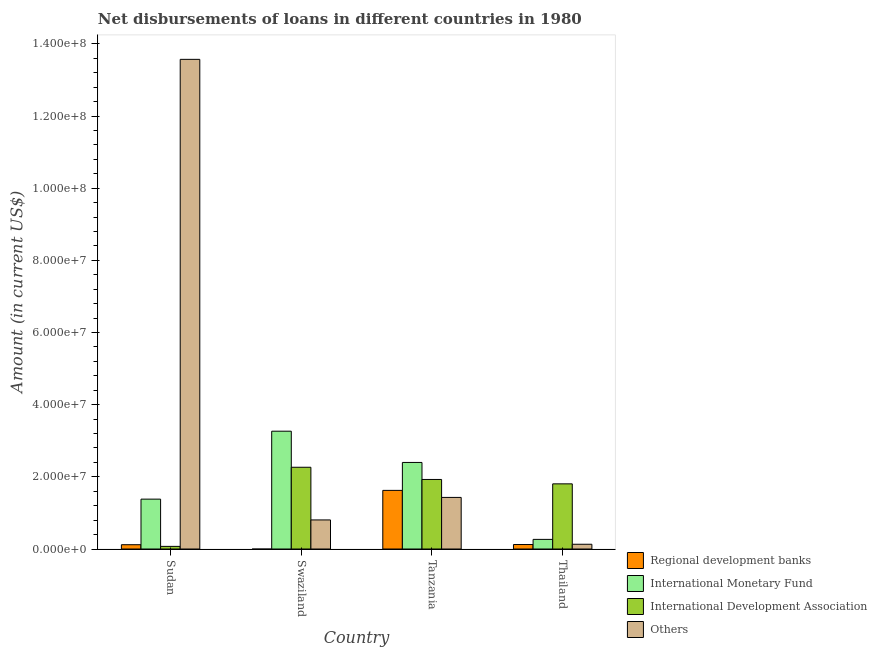How many different coloured bars are there?
Your answer should be compact. 4. Are the number of bars per tick equal to the number of legend labels?
Your answer should be compact. No. How many bars are there on the 1st tick from the left?
Keep it short and to the point. 4. What is the label of the 4th group of bars from the left?
Give a very brief answer. Thailand. In how many cases, is the number of bars for a given country not equal to the number of legend labels?
Offer a very short reply. 1. What is the amount of loan disimbursed by international development association in Swaziland?
Your answer should be very brief. 2.27e+07. Across all countries, what is the maximum amount of loan disimbursed by regional development banks?
Your answer should be compact. 1.62e+07. Across all countries, what is the minimum amount of loan disimbursed by international development association?
Your answer should be very brief. 7.26e+05. In which country was the amount of loan disimbursed by international monetary fund maximum?
Provide a succinct answer. Swaziland. What is the total amount of loan disimbursed by international development association in the graph?
Ensure brevity in your answer.  6.07e+07. What is the difference between the amount of loan disimbursed by other organisations in Tanzania and that in Thailand?
Make the answer very short. 1.30e+07. What is the difference between the amount of loan disimbursed by international monetary fund in Thailand and the amount of loan disimbursed by other organisations in Tanzania?
Your response must be concise. -1.16e+07. What is the average amount of loan disimbursed by regional development banks per country?
Provide a short and direct response. 4.67e+06. What is the difference between the amount of loan disimbursed by other organisations and amount of loan disimbursed by regional development banks in Sudan?
Provide a short and direct response. 1.35e+08. In how many countries, is the amount of loan disimbursed by international monetary fund greater than 80000000 US$?
Offer a terse response. 0. What is the ratio of the amount of loan disimbursed by regional development banks in Sudan to that in Thailand?
Make the answer very short. 0.96. Is the difference between the amount of loan disimbursed by other organisations in Tanzania and Thailand greater than the difference between the amount of loan disimbursed by international development association in Tanzania and Thailand?
Your response must be concise. Yes. What is the difference between the highest and the second highest amount of loan disimbursed by regional development banks?
Make the answer very short. 1.50e+07. What is the difference between the highest and the lowest amount of loan disimbursed by regional development banks?
Provide a short and direct response. 1.62e+07. Is it the case that in every country, the sum of the amount of loan disimbursed by regional development banks and amount of loan disimbursed by other organisations is greater than the sum of amount of loan disimbursed by international monetary fund and amount of loan disimbursed by international development association?
Offer a terse response. No. How many bars are there?
Your response must be concise. 15. Are the values on the major ticks of Y-axis written in scientific E-notation?
Your answer should be very brief. Yes. Does the graph contain any zero values?
Offer a terse response. Yes. Where does the legend appear in the graph?
Give a very brief answer. Bottom right. What is the title of the graph?
Your answer should be very brief. Net disbursements of loans in different countries in 1980. What is the Amount (in current US$) of Regional development banks in Sudan?
Your response must be concise. 1.19e+06. What is the Amount (in current US$) in International Monetary Fund in Sudan?
Offer a terse response. 1.38e+07. What is the Amount (in current US$) of International Development Association in Sudan?
Ensure brevity in your answer.  7.26e+05. What is the Amount (in current US$) in Others in Sudan?
Your answer should be very brief. 1.36e+08. What is the Amount (in current US$) in Regional development banks in Swaziland?
Your response must be concise. 0. What is the Amount (in current US$) in International Monetary Fund in Swaziland?
Provide a succinct answer. 3.27e+07. What is the Amount (in current US$) of International Development Association in Swaziland?
Your answer should be very brief. 2.27e+07. What is the Amount (in current US$) of Others in Swaziland?
Offer a very short reply. 8.06e+06. What is the Amount (in current US$) of Regional development banks in Tanzania?
Provide a short and direct response. 1.62e+07. What is the Amount (in current US$) in International Monetary Fund in Tanzania?
Keep it short and to the point. 2.40e+07. What is the Amount (in current US$) in International Development Association in Tanzania?
Your response must be concise. 1.93e+07. What is the Amount (in current US$) of Others in Tanzania?
Keep it short and to the point. 1.43e+07. What is the Amount (in current US$) of Regional development banks in Thailand?
Keep it short and to the point. 1.24e+06. What is the Amount (in current US$) of International Monetary Fund in Thailand?
Provide a short and direct response. 2.67e+06. What is the Amount (in current US$) of International Development Association in Thailand?
Make the answer very short. 1.81e+07. What is the Amount (in current US$) in Others in Thailand?
Provide a short and direct response. 1.32e+06. Across all countries, what is the maximum Amount (in current US$) in Regional development banks?
Make the answer very short. 1.62e+07. Across all countries, what is the maximum Amount (in current US$) in International Monetary Fund?
Your answer should be compact. 3.27e+07. Across all countries, what is the maximum Amount (in current US$) in International Development Association?
Your response must be concise. 2.27e+07. Across all countries, what is the maximum Amount (in current US$) of Others?
Your answer should be compact. 1.36e+08. Across all countries, what is the minimum Amount (in current US$) in International Monetary Fund?
Give a very brief answer. 2.67e+06. Across all countries, what is the minimum Amount (in current US$) of International Development Association?
Keep it short and to the point. 7.26e+05. Across all countries, what is the minimum Amount (in current US$) in Others?
Your response must be concise. 1.32e+06. What is the total Amount (in current US$) of Regional development banks in the graph?
Your response must be concise. 1.87e+07. What is the total Amount (in current US$) of International Monetary Fund in the graph?
Your response must be concise. 7.31e+07. What is the total Amount (in current US$) in International Development Association in the graph?
Offer a terse response. 6.07e+07. What is the total Amount (in current US$) in Others in the graph?
Give a very brief answer. 1.59e+08. What is the difference between the Amount (in current US$) in International Monetary Fund in Sudan and that in Swaziland?
Make the answer very short. -1.88e+07. What is the difference between the Amount (in current US$) in International Development Association in Sudan and that in Swaziland?
Your answer should be compact. -2.19e+07. What is the difference between the Amount (in current US$) in Others in Sudan and that in Swaziland?
Keep it short and to the point. 1.28e+08. What is the difference between the Amount (in current US$) of Regional development banks in Sudan and that in Tanzania?
Make the answer very short. -1.51e+07. What is the difference between the Amount (in current US$) in International Monetary Fund in Sudan and that in Tanzania?
Give a very brief answer. -1.02e+07. What is the difference between the Amount (in current US$) in International Development Association in Sudan and that in Tanzania?
Give a very brief answer. -1.86e+07. What is the difference between the Amount (in current US$) of Others in Sudan and that in Tanzania?
Provide a short and direct response. 1.21e+08. What is the difference between the Amount (in current US$) in Regional development banks in Sudan and that in Thailand?
Offer a terse response. -5.30e+04. What is the difference between the Amount (in current US$) of International Monetary Fund in Sudan and that in Thailand?
Ensure brevity in your answer.  1.12e+07. What is the difference between the Amount (in current US$) in International Development Association in Sudan and that in Thailand?
Provide a succinct answer. -1.73e+07. What is the difference between the Amount (in current US$) of Others in Sudan and that in Thailand?
Provide a succinct answer. 1.34e+08. What is the difference between the Amount (in current US$) in International Monetary Fund in Swaziland and that in Tanzania?
Ensure brevity in your answer.  8.66e+06. What is the difference between the Amount (in current US$) in International Development Association in Swaziland and that in Tanzania?
Your answer should be very brief. 3.38e+06. What is the difference between the Amount (in current US$) in Others in Swaziland and that in Tanzania?
Your response must be concise. -6.24e+06. What is the difference between the Amount (in current US$) of International Monetary Fund in Swaziland and that in Thailand?
Make the answer very short. 3.00e+07. What is the difference between the Amount (in current US$) of International Development Association in Swaziland and that in Thailand?
Your answer should be very brief. 4.60e+06. What is the difference between the Amount (in current US$) in Others in Swaziland and that in Thailand?
Make the answer very short. 6.74e+06. What is the difference between the Amount (in current US$) of Regional development banks in Tanzania and that in Thailand?
Provide a short and direct response. 1.50e+07. What is the difference between the Amount (in current US$) of International Monetary Fund in Tanzania and that in Thailand?
Offer a very short reply. 2.13e+07. What is the difference between the Amount (in current US$) in International Development Association in Tanzania and that in Thailand?
Offer a terse response. 1.22e+06. What is the difference between the Amount (in current US$) in Others in Tanzania and that in Thailand?
Ensure brevity in your answer.  1.30e+07. What is the difference between the Amount (in current US$) in Regional development banks in Sudan and the Amount (in current US$) in International Monetary Fund in Swaziland?
Offer a very short reply. -3.15e+07. What is the difference between the Amount (in current US$) in Regional development banks in Sudan and the Amount (in current US$) in International Development Association in Swaziland?
Your answer should be very brief. -2.15e+07. What is the difference between the Amount (in current US$) of Regional development banks in Sudan and the Amount (in current US$) of Others in Swaziland?
Your response must be concise. -6.87e+06. What is the difference between the Amount (in current US$) in International Monetary Fund in Sudan and the Amount (in current US$) in International Development Association in Swaziland?
Your answer should be very brief. -8.83e+06. What is the difference between the Amount (in current US$) in International Monetary Fund in Sudan and the Amount (in current US$) in Others in Swaziland?
Your response must be concise. 5.76e+06. What is the difference between the Amount (in current US$) of International Development Association in Sudan and the Amount (in current US$) of Others in Swaziland?
Offer a terse response. -7.33e+06. What is the difference between the Amount (in current US$) of Regional development banks in Sudan and the Amount (in current US$) of International Monetary Fund in Tanzania?
Keep it short and to the point. -2.28e+07. What is the difference between the Amount (in current US$) of Regional development banks in Sudan and the Amount (in current US$) of International Development Association in Tanzania?
Your answer should be very brief. -1.81e+07. What is the difference between the Amount (in current US$) of Regional development banks in Sudan and the Amount (in current US$) of Others in Tanzania?
Provide a short and direct response. -1.31e+07. What is the difference between the Amount (in current US$) in International Monetary Fund in Sudan and the Amount (in current US$) in International Development Association in Tanzania?
Offer a terse response. -5.45e+06. What is the difference between the Amount (in current US$) of International Monetary Fund in Sudan and the Amount (in current US$) of Others in Tanzania?
Provide a short and direct response. -4.75e+05. What is the difference between the Amount (in current US$) in International Development Association in Sudan and the Amount (in current US$) in Others in Tanzania?
Provide a short and direct response. -1.36e+07. What is the difference between the Amount (in current US$) in Regional development banks in Sudan and the Amount (in current US$) in International Monetary Fund in Thailand?
Ensure brevity in your answer.  -1.48e+06. What is the difference between the Amount (in current US$) of Regional development banks in Sudan and the Amount (in current US$) of International Development Association in Thailand?
Offer a terse response. -1.69e+07. What is the difference between the Amount (in current US$) in Regional development banks in Sudan and the Amount (in current US$) in Others in Thailand?
Make the answer very short. -1.27e+05. What is the difference between the Amount (in current US$) of International Monetary Fund in Sudan and the Amount (in current US$) of International Development Association in Thailand?
Give a very brief answer. -4.24e+06. What is the difference between the Amount (in current US$) of International Monetary Fund in Sudan and the Amount (in current US$) of Others in Thailand?
Make the answer very short. 1.25e+07. What is the difference between the Amount (in current US$) in International Development Association in Sudan and the Amount (in current US$) in Others in Thailand?
Provide a succinct answer. -5.90e+05. What is the difference between the Amount (in current US$) in International Monetary Fund in Swaziland and the Amount (in current US$) in International Development Association in Tanzania?
Your response must be concise. 1.34e+07. What is the difference between the Amount (in current US$) in International Monetary Fund in Swaziland and the Amount (in current US$) in Others in Tanzania?
Give a very brief answer. 1.84e+07. What is the difference between the Amount (in current US$) in International Development Association in Swaziland and the Amount (in current US$) in Others in Tanzania?
Ensure brevity in your answer.  8.36e+06. What is the difference between the Amount (in current US$) of International Monetary Fund in Swaziland and the Amount (in current US$) of International Development Association in Thailand?
Provide a succinct answer. 1.46e+07. What is the difference between the Amount (in current US$) of International Monetary Fund in Swaziland and the Amount (in current US$) of Others in Thailand?
Offer a very short reply. 3.13e+07. What is the difference between the Amount (in current US$) in International Development Association in Swaziland and the Amount (in current US$) in Others in Thailand?
Keep it short and to the point. 2.13e+07. What is the difference between the Amount (in current US$) of Regional development banks in Tanzania and the Amount (in current US$) of International Monetary Fund in Thailand?
Keep it short and to the point. 1.36e+07. What is the difference between the Amount (in current US$) in Regional development banks in Tanzania and the Amount (in current US$) in International Development Association in Thailand?
Your response must be concise. -1.81e+06. What is the difference between the Amount (in current US$) in Regional development banks in Tanzania and the Amount (in current US$) in Others in Thailand?
Make the answer very short. 1.49e+07. What is the difference between the Amount (in current US$) of International Monetary Fund in Tanzania and the Amount (in current US$) of International Development Association in Thailand?
Offer a very short reply. 5.93e+06. What is the difference between the Amount (in current US$) in International Monetary Fund in Tanzania and the Amount (in current US$) in Others in Thailand?
Offer a very short reply. 2.27e+07. What is the difference between the Amount (in current US$) in International Development Association in Tanzania and the Amount (in current US$) in Others in Thailand?
Provide a short and direct response. 1.80e+07. What is the average Amount (in current US$) of Regional development banks per country?
Your answer should be very brief. 4.67e+06. What is the average Amount (in current US$) in International Monetary Fund per country?
Your answer should be very brief. 1.83e+07. What is the average Amount (in current US$) in International Development Association per country?
Offer a very short reply. 1.52e+07. What is the average Amount (in current US$) of Others per country?
Provide a succinct answer. 3.98e+07. What is the difference between the Amount (in current US$) in Regional development banks and Amount (in current US$) in International Monetary Fund in Sudan?
Your response must be concise. -1.26e+07. What is the difference between the Amount (in current US$) in Regional development banks and Amount (in current US$) in International Development Association in Sudan?
Your answer should be compact. 4.63e+05. What is the difference between the Amount (in current US$) of Regional development banks and Amount (in current US$) of Others in Sudan?
Provide a succinct answer. -1.35e+08. What is the difference between the Amount (in current US$) of International Monetary Fund and Amount (in current US$) of International Development Association in Sudan?
Keep it short and to the point. 1.31e+07. What is the difference between the Amount (in current US$) in International Monetary Fund and Amount (in current US$) in Others in Sudan?
Your answer should be compact. -1.22e+08. What is the difference between the Amount (in current US$) of International Development Association and Amount (in current US$) of Others in Sudan?
Keep it short and to the point. -1.35e+08. What is the difference between the Amount (in current US$) in International Monetary Fund and Amount (in current US$) in International Development Association in Swaziland?
Ensure brevity in your answer.  1.00e+07. What is the difference between the Amount (in current US$) in International Monetary Fund and Amount (in current US$) in Others in Swaziland?
Your answer should be compact. 2.46e+07. What is the difference between the Amount (in current US$) of International Development Association and Amount (in current US$) of Others in Swaziland?
Your answer should be compact. 1.46e+07. What is the difference between the Amount (in current US$) of Regional development banks and Amount (in current US$) of International Monetary Fund in Tanzania?
Make the answer very short. -7.74e+06. What is the difference between the Amount (in current US$) of Regional development banks and Amount (in current US$) of International Development Association in Tanzania?
Make the answer very short. -3.03e+06. What is the difference between the Amount (in current US$) of Regional development banks and Amount (in current US$) of Others in Tanzania?
Offer a very short reply. 1.95e+06. What is the difference between the Amount (in current US$) of International Monetary Fund and Amount (in current US$) of International Development Association in Tanzania?
Make the answer very short. 4.71e+06. What is the difference between the Amount (in current US$) in International Monetary Fund and Amount (in current US$) in Others in Tanzania?
Provide a short and direct response. 9.69e+06. What is the difference between the Amount (in current US$) of International Development Association and Amount (in current US$) of Others in Tanzania?
Your answer should be compact. 4.98e+06. What is the difference between the Amount (in current US$) of Regional development banks and Amount (in current US$) of International Monetary Fund in Thailand?
Ensure brevity in your answer.  -1.42e+06. What is the difference between the Amount (in current US$) of Regional development banks and Amount (in current US$) of International Development Association in Thailand?
Your response must be concise. -1.68e+07. What is the difference between the Amount (in current US$) of Regional development banks and Amount (in current US$) of Others in Thailand?
Offer a terse response. -7.40e+04. What is the difference between the Amount (in current US$) of International Monetary Fund and Amount (in current US$) of International Development Association in Thailand?
Your response must be concise. -1.54e+07. What is the difference between the Amount (in current US$) of International Monetary Fund and Amount (in current US$) of Others in Thailand?
Your answer should be very brief. 1.35e+06. What is the difference between the Amount (in current US$) of International Development Association and Amount (in current US$) of Others in Thailand?
Your answer should be very brief. 1.67e+07. What is the ratio of the Amount (in current US$) in International Monetary Fund in Sudan to that in Swaziland?
Your response must be concise. 0.42. What is the ratio of the Amount (in current US$) in International Development Association in Sudan to that in Swaziland?
Keep it short and to the point. 0.03. What is the ratio of the Amount (in current US$) of Others in Sudan to that in Swaziland?
Offer a very short reply. 16.84. What is the ratio of the Amount (in current US$) in Regional development banks in Sudan to that in Tanzania?
Ensure brevity in your answer.  0.07. What is the ratio of the Amount (in current US$) in International Monetary Fund in Sudan to that in Tanzania?
Provide a succinct answer. 0.58. What is the ratio of the Amount (in current US$) in International Development Association in Sudan to that in Tanzania?
Offer a very short reply. 0.04. What is the ratio of the Amount (in current US$) in Others in Sudan to that in Tanzania?
Provide a succinct answer. 9.49. What is the ratio of the Amount (in current US$) in Regional development banks in Sudan to that in Thailand?
Keep it short and to the point. 0.96. What is the ratio of the Amount (in current US$) of International Monetary Fund in Sudan to that in Thailand?
Provide a short and direct response. 5.19. What is the ratio of the Amount (in current US$) in International Development Association in Sudan to that in Thailand?
Offer a terse response. 0.04. What is the ratio of the Amount (in current US$) in Others in Sudan to that in Thailand?
Make the answer very short. 103.13. What is the ratio of the Amount (in current US$) in International Monetary Fund in Swaziland to that in Tanzania?
Your answer should be very brief. 1.36. What is the ratio of the Amount (in current US$) of International Development Association in Swaziland to that in Tanzania?
Provide a succinct answer. 1.18. What is the ratio of the Amount (in current US$) of Others in Swaziland to that in Tanzania?
Offer a very short reply. 0.56. What is the ratio of the Amount (in current US$) in International Monetary Fund in Swaziland to that in Thailand?
Offer a terse response. 12.25. What is the ratio of the Amount (in current US$) in International Development Association in Swaziland to that in Thailand?
Provide a short and direct response. 1.25. What is the ratio of the Amount (in current US$) of Others in Swaziland to that in Thailand?
Give a very brief answer. 6.12. What is the ratio of the Amount (in current US$) of Regional development banks in Tanzania to that in Thailand?
Make the answer very short. 13.08. What is the ratio of the Amount (in current US$) in International Monetary Fund in Tanzania to that in Thailand?
Your answer should be very brief. 9. What is the ratio of the Amount (in current US$) in International Development Association in Tanzania to that in Thailand?
Your response must be concise. 1.07. What is the ratio of the Amount (in current US$) of Others in Tanzania to that in Thailand?
Ensure brevity in your answer.  10.87. What is the difference between the highest and the second highest Amount (in current US$) in Regional development banks?
Offer a terse response. 1.50e+07. What is the difference between the highest and the second highest Amount (in current US$) in International Monetary Fund?
Your answer should be compact. 8.66e+06. What is the difference between the highest and the second highest Amount (in current US$) of International Development Association?
Your answer should be compact. 3.38e+06. What is the difference between the highest and the second highest Amount (in current US$) in Others?
Give a very brief answer. 1.21e+08. What is the difference between the highest and the lowest Amount (in current US$) in Regional development banks?
Offer a very short reply. 1.62e+07. What is the difference between the highest and the lowest Amount (in current US$) in International Monetary Fund?
Offer a very short reply. 3.00e+07. What is the difference between the highest and the lowest Amount (in current US$) of International Development Association?
Your answer should be very brief. 2.19e+07. What is the difference between the highest and the lowest Amount (in current US$) of Others?
Your response must be concise. 1.34e+08. 